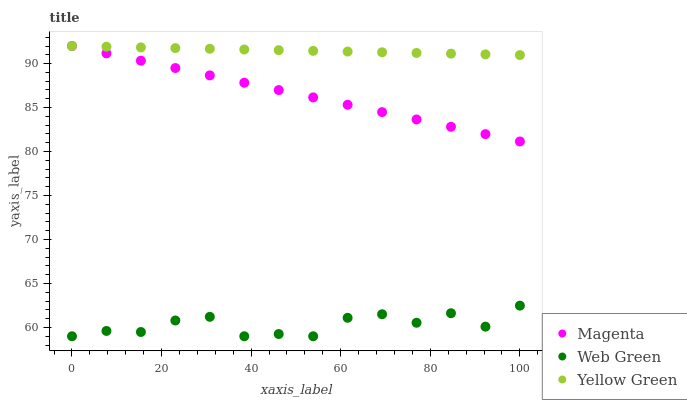Does Web Green have the minimum area under the curve?
Answer yes or no. Yes. Does Yellow Green have the maximum area under the curve?
Answer yes or no. Yes. Does Yellow Green have the minimum area under the curve?
Answer yes or no. No. Does Web Green have the maximum area under the curve?
Answer yes or no. No. Is Yellow Green the smoothest?
Answer yes or no. Yes. Is Web Green the roughest?
Answer yes or no. Yes. Is Web Green the smoothest?
Answer yes or no. No. Is Yellow Green the roughest?
Answer yes or no. No. Does Web Green have the lowest value?
Answer yes or no. Yes. Does Yellow Green have the lowest value?
Answer yes or no. No. Does Yellow Green have the highest value?
Answer yes or no. Yes. Does Web Green have the highest value?
Answer yes or no. No. Is Web Green less than Yellow Green?
Answer yes or no. Yes. Is Magenta greater than Web Green?
Answer yes or no. Yes. Does Magenta intersect Yellow Green?
Answer yes or no. Yes. Is Magenta less than Yellow Green?
Answer yes or no. No. Is Magenta greater than Yellow Green?
Answer yes or no. No. Does Web Green intersect Yellow Green?
Answer yes or no. No. 